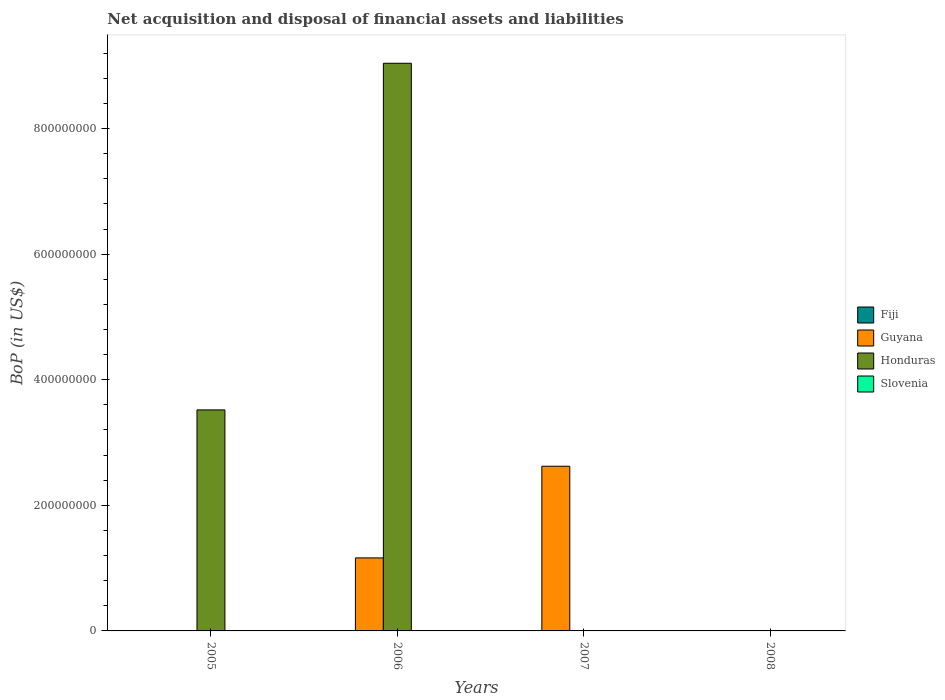Are the number of bars per tick equal to the number of legend labels?
Offer a terse response. No. Are the number of bars on each tick of the X-axis equal?
Offer a very short reply. No. How many bars are there on the 2nd tick from the left?
Your response must be concise. 2. What is the Balance of Payments in Slovenia in 2008?
Provide a succinct answer. 0. Across all years, what is the maximum Balance of Payments in Guyana?
Your answer should be very brief. 2.62e+08. Across all years, what is the minimum Balance of Payments in Honduras?
Your answer should be compact. 0. What is the total Balance of Payments in Honduras in the graph?
Your answer should be very brief. 1.26e+09. What is the difference between the Balance of Payments in Honduras in 2005 and that in 2006?
Offer a very short reply. -5.52e+08. What is the difference between the Balance of Payments in Guyana in 2007 and the Balance of Payments in Honduras in 2006?
Your answer should be compact. -6.42e+08. In the year 2006, what is the difference between the Balance of Payments in Honduras and Balance of Payments in Guyana?
Your answer should be compact. 7.88e+08. In how many years, is the Balance of Payments in Guyana greater than 360000000 US$?
Give a very brief answer. 0. What is the ratio of the Balance of Payments in Guyana in 2006 to that in 2007?
Your response must be concise. 0.44. What is the difference between the highest and the lowest Balance of Payments in Honduras?
Keep it short and to the point. 9.04e+08. In how many years, is the Balance of Payments in Honduras greater than the average Balance of Payments in Honduras taken over all years?
Give a very brief answer. 2. Is it the case that in every year, the sum of the Balance of Payments in Slovenia and Balance of Payments in Honduras is greater than the Balance of Payments in Guyana?
Make the answer very short. No. How many bars are there?
Your answer should be very brief. 4. Are all the bars in the graph horizontal?
Ensure brevity in your answer.  No. Does the graph contain any zero values?
Provide a short and direct response. Yes. Where does the legend appear in the graph?
Provide a short and direct response. Center right. What is the title of the graph?
Offer a terse response. Net acquisition and disposal of financial assets and liabilities. Does "Antigua and Barbuda" appear as one of the legend labels in the graph?
Your answer should be very brief. No. What is the label or title of the X-axis?
Your answer should be very brief. Years. What is the label or title of the Y-axis?
Your answer should be compact. BoP (in US$). What is the BoP (in US$) of Honduras in 2005?
Offer a terse response. 3.52e+08. What is the BoP (in US$) of Guyana in 2006?
Your answer should be very brief. 1.16e+08. What is the BoP (in US$) in Honduras in 2006?
Give a very brief answer. 9.04e+08. What is the BoP (in US$) of Guyana in 2007?
Give a very brief answer. 2.62e+08. What is the BoP (in US$) in Slovenia in 2007?
Make the answer very short. 0. What is the BoP (in US$) in Guyana in 2008?
Provide a succinct answer. 0. What is the BoP (in US$) in Honduras in 2008?
Keep it short and to the point. 0. Across all years, what is the maximum BoP (in US$) in Guyana?
Make the answer very short. 2.62e+08. Across all years, what is the maximum BoP (in US$) of Honduras?
Your response must be concise. 9.04e+08. Across all years, what is the minimum BoP (in US$) of Guyana?
Your answer should be compact. 0. Across all years, what is the minimum BoP (in US$) of Honduras?
Your answer should be compact. 0. What is the total BoP (in US$) in Fiji in the graph?
Ensure brevity in your answer.  0. What is the total BoP (in US$) of Guyana in the graph?
Your response must be concise. 3.79e+08. What is the total BoP (in US$) in Honduras in the graph?
Give a very brief answer. 1.26e+09. What is the total BoP (in US$) of Slovenia in the graph?
Provide a succinct answer. 0. What is the difference between the BoP (in US$) in Honduras in 2005 and that in 2006?
Offer a very short reply. -5.52e+08. What is the difference between the BoP (in US$) of Guyana in 2006 and that in 2007?
Keep it short and to the point. -1.46e+08. What is the average BoP (in US$) of Guyana per year?
Your response must be concise. 9.46e+07. What is the average BoP (in US$) in Honduras per year?
Keep it short and to the point. 3.14e+08. In the year 2006, what is the difference between the BoP (in US$) in Guyana and BoP (in US$) in Honduras?
Your response must be concise. -7.88e+08. What is the ratio of the BoP (in US$) in Honduras in 2005 to that in 2006?
Offer a very short reply. 0.39. What is the ratio of the BoP (in US$) of Guyana in 2006 to that in 2007?
Provide a succinct answer. 0.44. What is the difference between the highest and the lowest BoP (in US$) of Guyana?
Your response must be concise. 2.62e+08. What is the difference between the highest and the lowest BoP (in US$) of Honduras?
Provide a succinct answer. 9.04e+08. 